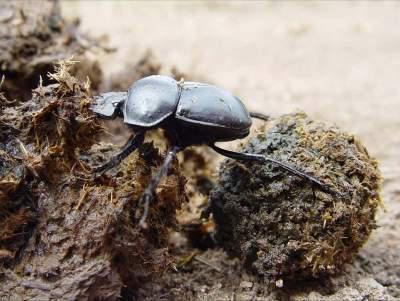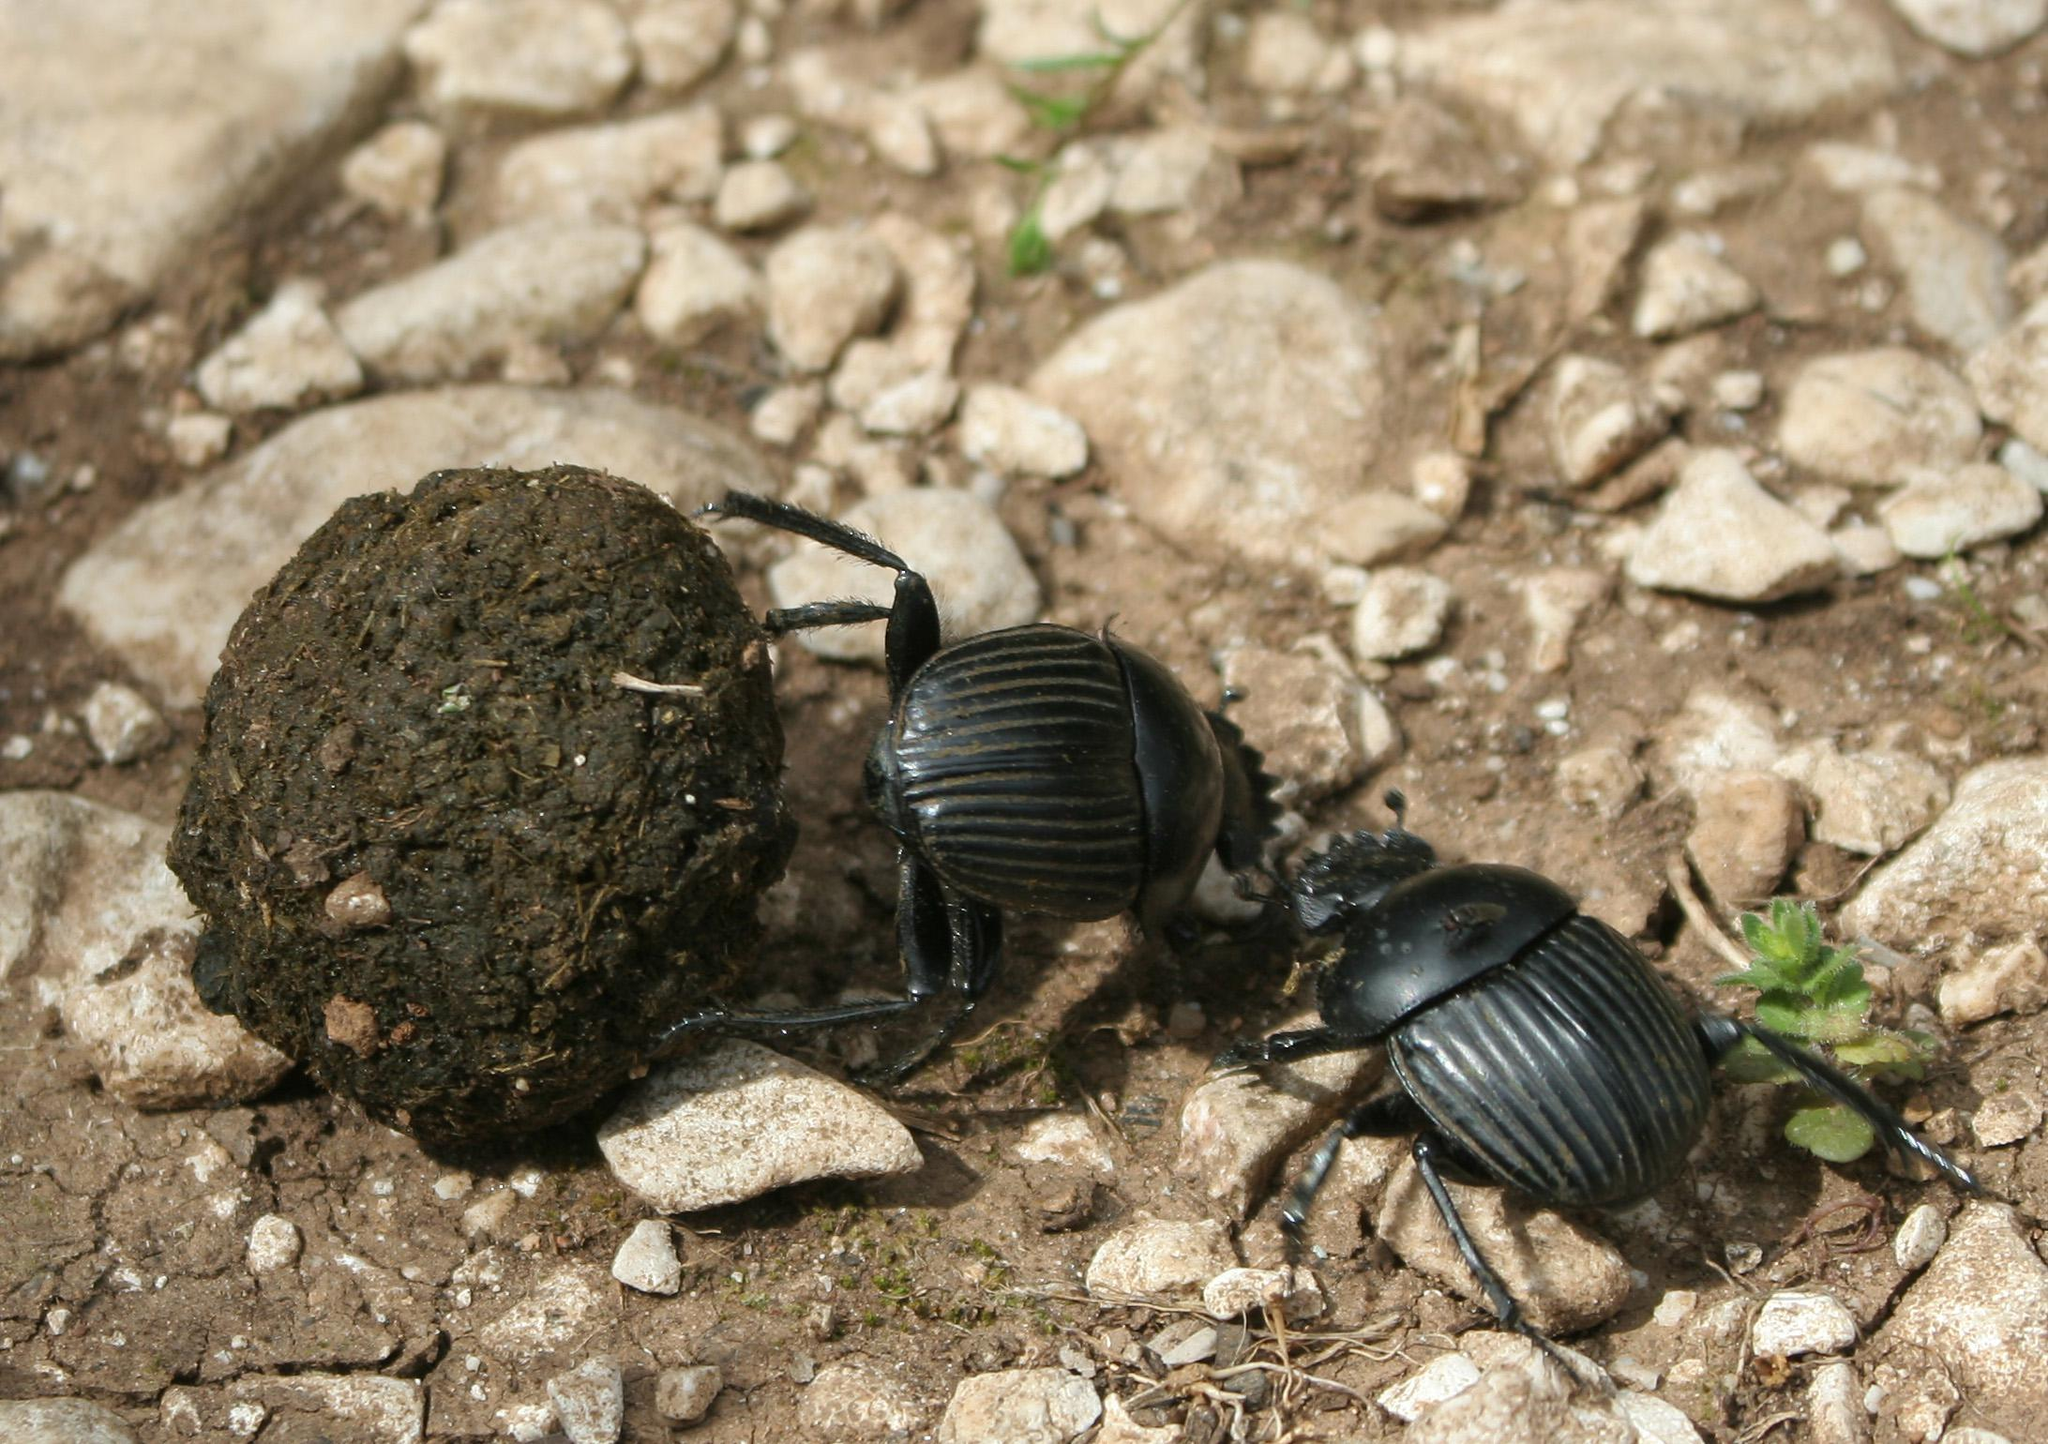The first image is the image on the left, the second image is the image on the right. Assess this claim about the two images: "There are multiple beetles near the dung in one of the images.". Correct or not? Answer yes or no. Yes. The first image is the image on the left, the second image is the image on the right. Considering the images on both sides, is "Each image includes at least one brown ball and one beetle in contact with it, but no image contains more than two beetles." valid? Answer yes or no. Yes. 